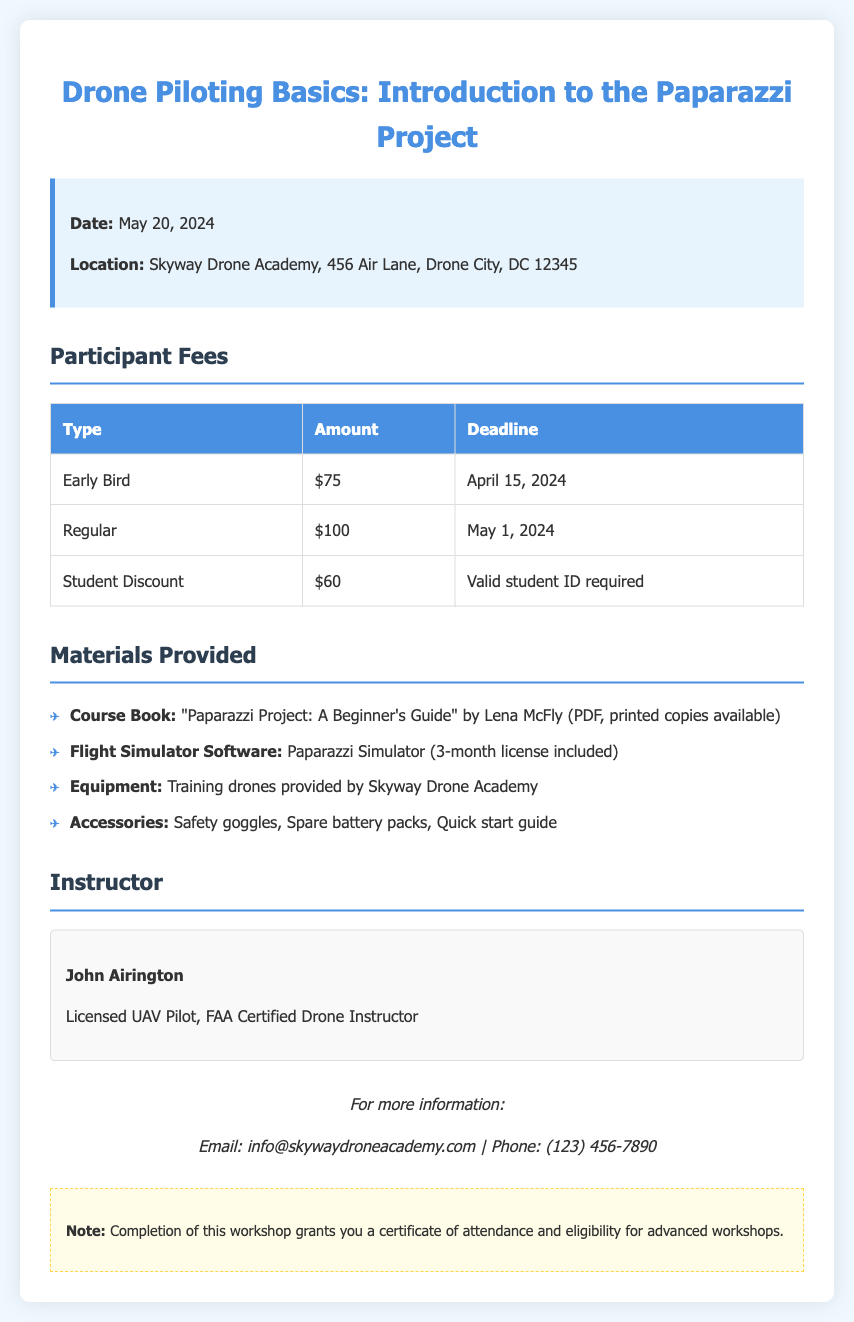What is the workshop date? The workshop date is mentioned in the document as May 20, 2024.
Answer: May 20, 2024 What is the location of the workshop? The document specifies the workshop location as Skyway Drone Academy, 456 Air Lane, Drone City, DC 12345.
Answer: Skyway Drone Academy, 456 Air Lane, Drone City, DC 12345 What is the amount for the Early Bird fee? The document lists the Early Bird fee amount as $75.
Answer: $75 What materials are provided in the workshop? The materials provided include course book, flight simulator software, equipment, and accessories.
Answer: Course book, flight simulator software, equipment, accessories Who is the instructor for this workshop? The document names John Airington as the instructor for the workshop.
Answer: John Airington What is the total amount for Regular fee and Student Discount combined? The Regular fee is $100 and the Student Discount is $60; adding them gives $160.
Answer: $160 How many licenses for the Paparazzi Simulator are included? The document indicates that a 3-month license for the flight simulator software is included.
Answer: 3-month What is the email address provided for more information? The document provides the email address as info@skywaydroneacademy.com.
Answer: info@skywaydroneacademy.com What does completion of the workshop grant? The document states that completion grants a certificate of attendance and eligibility for advanced workshops.
Answer: A certificate of attendance and eligibility for advanced workshops 